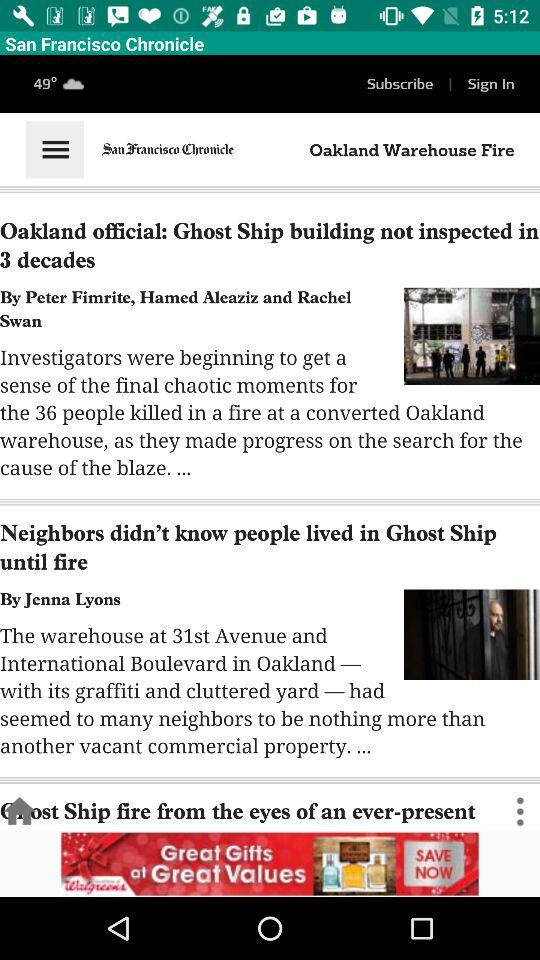Who's the author of "Oakland official: Ghost Ship building not inspected in 3 decades"? The authors are Peter Fimrite, Hamed Aleaziz and Rachel Swan. 